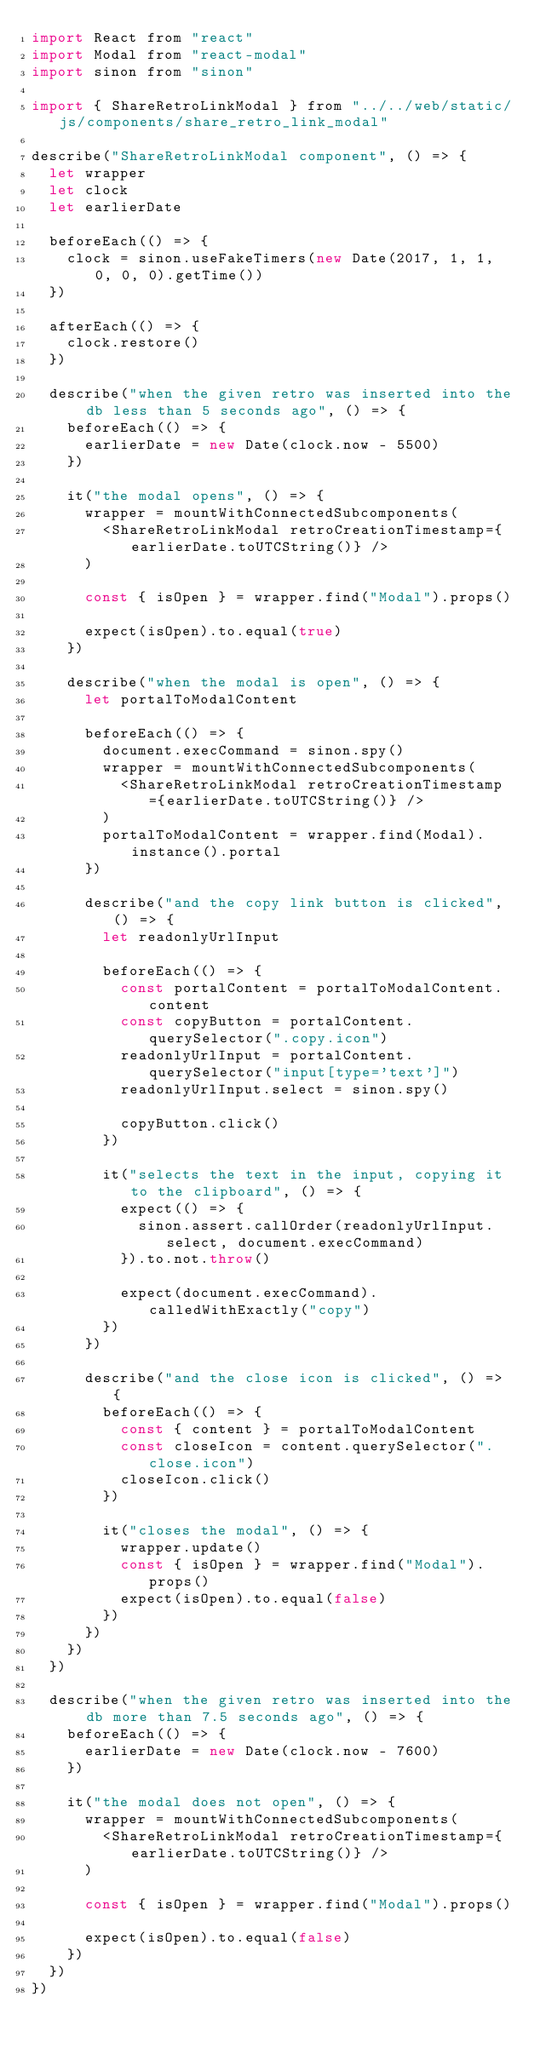Convert code to text. <code><loc_0><loc_0><loc_500><loc_500><_JavaScript_>import React from "react"
import Modal from "react-modal"
import sinon from "sinon"

import { ShareRetroLinkModal } from "../../web/static/js/components/share_retro_link_modal"

describe("ShareRetroLinkModal component", () => {
  let wrapper
  let clock
  let earlierDate

  beforeEach(() => {
    clock = sinon.useFakeTimers(new Date(2017, 1, 1, 0, 0, 0).getTime())
  })

  afterEach(() => {
    clock.restore()
  })

  describe("when the given retro was inserted into the db less than 5 seconds ago", () => {
    beforeEach(() => {
      earlierDate = new Date(clock.now - 5500)
    })

    it("the modal opens", () => {
      wrapper = mountWithConnectedSubcomponents(
        <ShareRetroLinkModal retroCreationTimestamp={earlierDate.toUTCString()} />
      )

      const { isOpen } = wrapper.find("Modal").props()

      expect(isOpen).to.equal(true)
    })

    describe("when the modal is open", () => {
      let portalToModalContent

      beforeEach(() => {
        document.execCommand = sinon.spy()
        wrapper = mountWithConnectedSubcomponents(
          <ShareRetroLinkModal retroCreationTimestamp={earlierDate.toUTCString()} />
        )
        portalToModalContent = wrapper.find(Modal).instance().portal
      })

      describe("and the copy link button is clicked", () => {
        let readonlyUrlInput

        beforeEach(() => {
          const portalContent = portalToModalContent.content
          const copyButton = portalContent.querySelector(".copy.icon")
          readonlyUrlInput = portalContent.querySelector("input[type='text']")
          readonlyUrlInput.select = sinon.spy()

          copyButton.click()
        })

        it("selects the text in the input, copying it to the clipboard", () => {
          expect(() => {
            sinon.assert.callOrder(readonlyUrlInput.select, document.execCommand)
          }).to.not.throw()

          expect(document.execCommand).calledWithExactly("copy")
        })
      })

      describe("and the close icon is clicked", () => {
        beforeEach(() => {
          const { content } = portalToModalContent
          const closeIcon = content.querySelector(".close.icon")
          closeIcon.click()
        })

        it("closes the modal", () => {
          wrapper.update()
          const { isOpen } = wrapper.find("Modal").props()
          expect(isOpen).to.equal(false)
        })
      })
    })
  })

  describe("when the given retro was inserted into the db more than 7.5 seconds ago", () => {
    beforeEach(() => {
      earlierDate = new Date(clock.now - 7600)
    })

    it("the modal does not open", () => {
      wrapper = mountWithConnectedSubcomponents(
        <ShareRetroLinkModal retroCreationTimestamp={earlierDate.toUTCString()} />
      )

      const { isOpen } = wrapper.find("Modal").props()

      expect(isOpen).to.equal(false)
    })
  })
})
</code> 